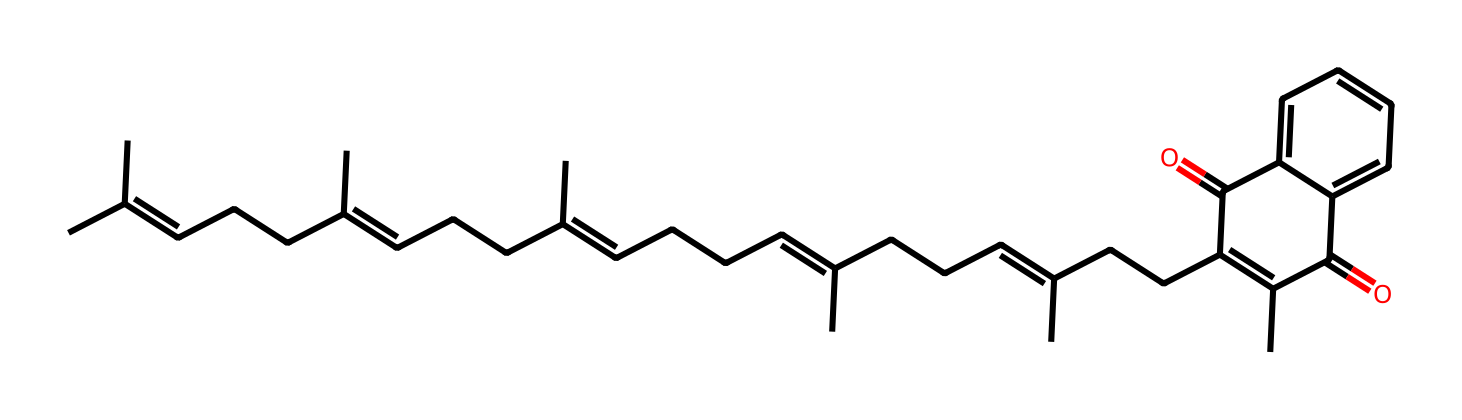What is the main functional group present in vitamin K2? The main functional group in vitamin K2 is the quinone structure, which is indicated by the presence of the double-bonded oxygen atoms (C=O).
Answer: quinone How many carbon atoms are present in the structure? By analyzing the SMILES representation, we can count the number of carbon symbols (C) in the formula which totals 30 carbon atoms in the structure.
Answer: 30 What type of vitamin is represented by this chemical structure? Based on the structure and its name, which specifies its role in blood clotting, this chemical is identified as a fat-soluble vitamin.
Answer: fat-soluble What role does vitamin K2 play in the body? The primary biological function of vitamin K2 is related to its role in the synthesis of proteins involved in blood coagulation, specifically promoting the activity of clotting factors.
Answer: blood clotting How many double bonds are present in the structure? By inspecting the chemical structure, we can see that there are several instances of double bonds. Counting them from the structure reveals there are 7 double bonds.
Answer: 7 Which part of the molecule is responsible for its bioactivity in blood clotting? The bioactivity is associated with the side chains in the structure, particularly due to the presence of the unsaturated bonds that contribute to the molecule's reactivity and involvement in biological processes.
Answer: side chains 